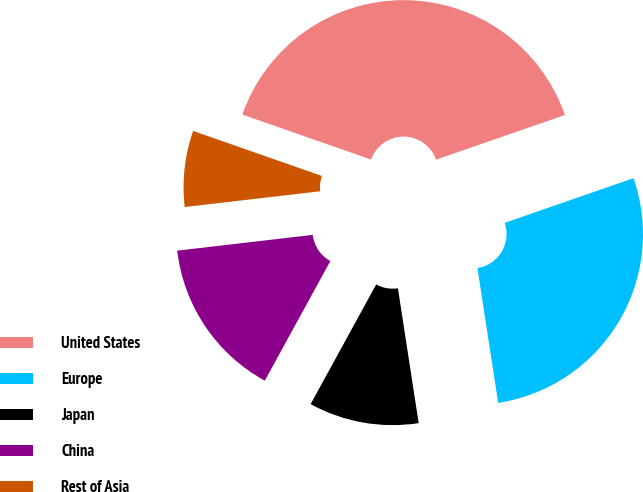Convert chart. <chart><loc_0><loc_0><loc_500><loc_500><pie_chart><fcel>United States<fcel>Europe<fcel>Japan<fcel>China<fcel>Rest of Asia<nl><fcel>39.34%<fcel>27.88%<fcel>10.41%<fcel>15.18%<fcel>7.2%<nl></chart> 